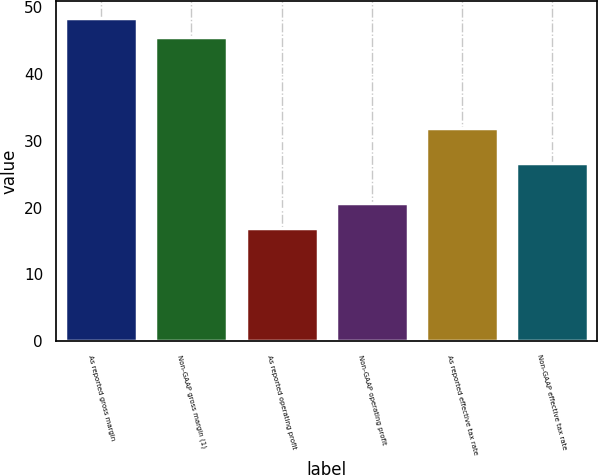Convert chart to OTSL. <chart><loc_0><loc_0><loc_500><loc_500><bar_chart><fcel>As reported gross margin<fcel>Non-GAAP gross margin (1)<fcel>As reported operating profit<fcel>Non-GAAP operating profit<fcel>As reported effective tax rate<fcel>Non-GAAP effective tax rate<nl><fcel>48.48<fcel>45.6<fcel>17<fcel>20.7<fcel>31.9<fcel>26.7<nl></chart> 